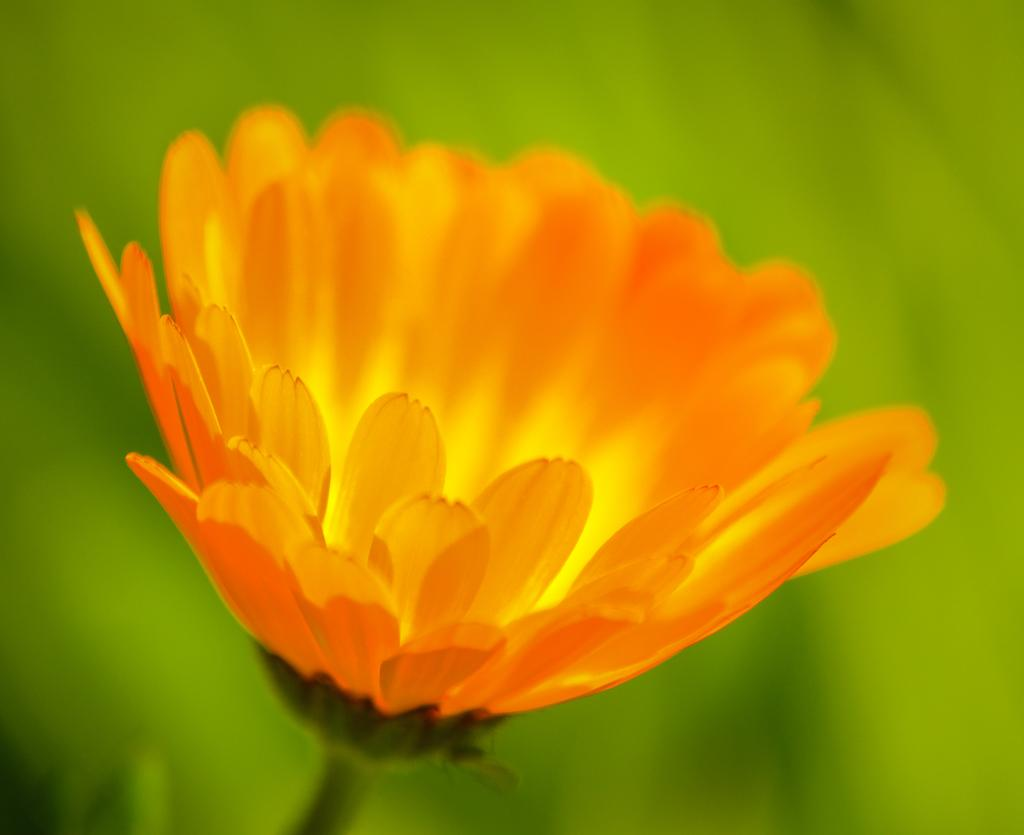What is the main subject of the image? There is a flower in the image. Can you describe the background of the image? The background of the image is blue and green. How many rings are visible on the stem of the flower in the image? There are no rings visible on the stem of the flower in the image, as the stem is not shown in the image. What type of passenger is sitting next to the flower in the image? There is no passenger present in the image, as it only features a flower and the background. 